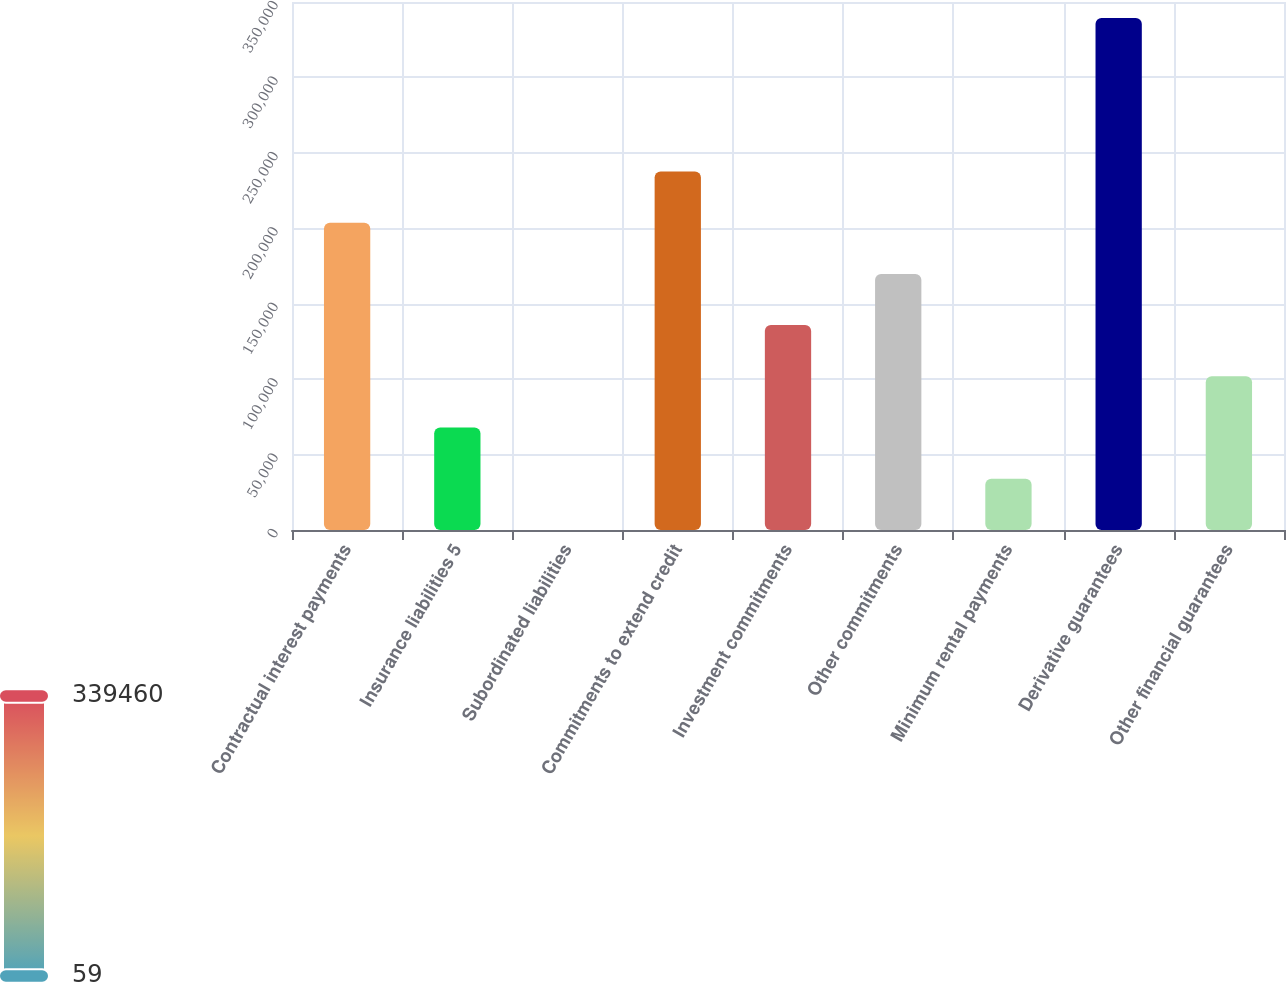Convert chart to OTSL. <chart><loc_0><loc_0><loc_500><loc_500><bar_chart><fcel>Contractual interest payments<fcel>Insurance liabilities 5<fcel>Subordinated liabilities<fcel>Commitments to extend credit<fcel>Investment commitments<fcel>Other commitments<fcel>Minimum rental payments<fcel>Derivative guarantees<fcel>Other financial guarantees<nl><fcel>203700<fcel>67939.2<fcel>59<fcel>237640<fcel>135819<fcel>169760<fcel>33999.1<fcel>339460<fcel>101879<nl></chart> 